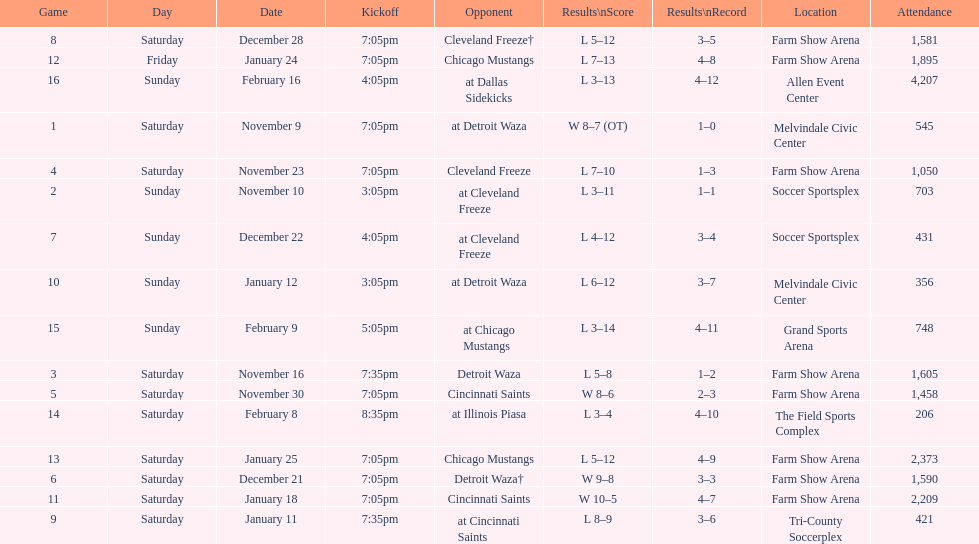When the harrisburg heat scored eight or more goals, how many of those games did they win? 4. Can you give me this table as a dict? {'header': ['Game', 'Day', 'Date', 'Kickoff', 'Opponent', 'Results\\nScore', 'Results\\nRecord', 'Location', 'Attendance'], 'rows': [['8', 'Saturday', 'December 28', '7:05pm', 'Cleveland Freeze†', 'L 5–12', '3–5', 'Farm Show Arena', '1,581'], ['12', 'Friday', 'January 24', '7:05pm', 'Chicago Mustangs', 'L 7–13', '4–8', 'Farm Show Arena', '1,895'], ['16', 'Sunday', 'February 16', '4:05pm', 'at Dallas Sidekicks', 'L 3–13', '4–12', 'Allen Event Center', '4,207'], ['1', 'Saturday', 'November 9', '7:05pm', 'at Detroit Waza', 'W 8–7 (OT)', '1–0', 'Melvindale Civic Center', '545'], ['4', 'Saturday', 'November 23', '7:05pm', 'Cleveland Freeze', 'L 7–10', '1–3', 'Farm Show Arena', '1,050'], ['2', 'Sunday', 'November 10', '3:05pm', 'at Cleveland Freeze', 'L 3–11', '1–1', 'Soccer Sportsplex', '703'], ['7', 'Sunday', 'December 22', '4:05pm', 'at Cleveland Freeze', 'L 4–12', '3–4', 'Soccer Sportsplex', '431'], ['10', 'Sunday', 'January 12', '3:05pm', 'at Detroit Waza', 'L 6–12', '3–7', 'Melvindale Civic Center', '356'], ['15', 'Sunday', 'February 9', '5:05pm', 'at Chicago Mustangs', 'L 3–14', '4–11', 'Grand Sports Arena', '748'], ['3', 'Saturday', 'November 16', '7:35pm', 'Detroit Waza', 'L 5–8', '1–2', 'Farm Show Arena', '1,605'], ['5', 'Saturday', 'November 30', '7:05pm', 'Cincinnati Saints', 'W 8–6', '2–3', 'Farm Show Arena', '1,458'], ['14', 'Saturday', 'February 8', '8:35pm', 'at Illinois Piasa', 'L 3–4', '4–10', 'The Field Sports Complex', '206'], ['13', 'Saturday', 'January 25', '7:05pm', 'Chicago Mustangs', 'L 5–12', '4–9', 'Farm Show Arena', '2,373'], ['6', 'Saturday', 'December 21', '7:05pm', 'Detroit Waza†', 'W 9–8', '3–3', 'Farm Show Arena', '1,590'], ['11', 'Saturday', 'January 18', '7:05pm', 'Cincinnati Saints', 'W 10–5', '4–7', 'Farm Show Arena', '2,209'], ['9', 'Saturday', 'January 11', '7:35pm', 'at Cincinnati Saints', 'L 8–9', '3–6', 'Tri-County Soccerplex', '421']]} 